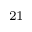Convert formula to latex. <formula><loc_0><loc_0><loc_500><loc_500>^ { 2 1 }</formula> 